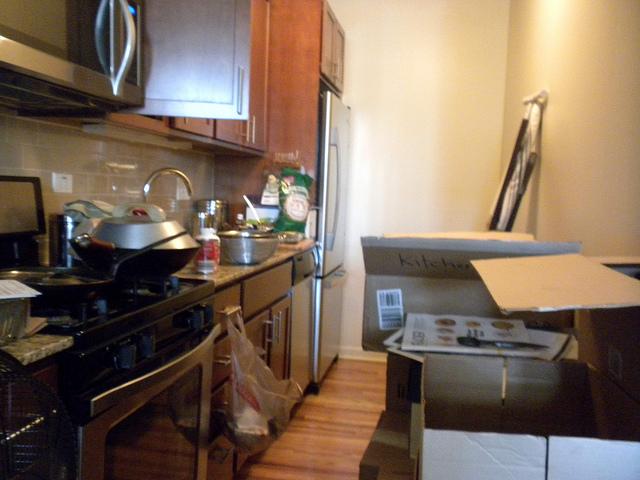What room of the house is this?
Concise answer only. Kitchen. What is the floor made out of?
Quick response, please. Wood. What do you use the stove for?
Write a very short answer. Cooking. 